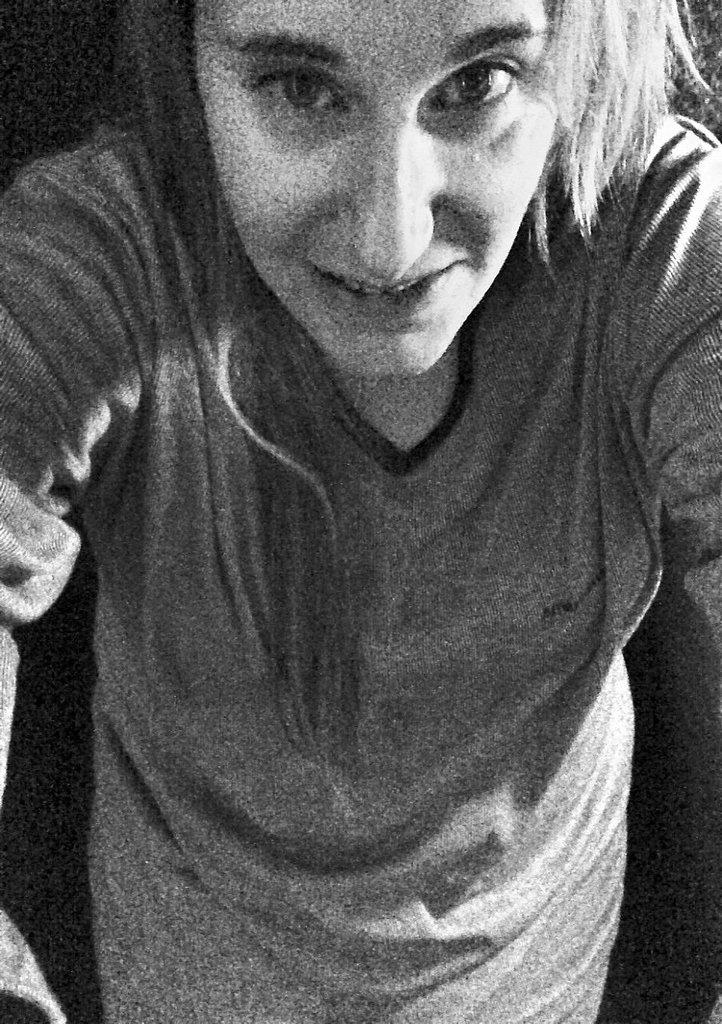What is the main subject of the image? There is a person in the image. What is the person doing in the image? The person is standing. What is the person's facial expression in the image? The person is smiling. What type of business is being conducted in the image? There is no indication of any business being conducted in the image; it simply shows a person standing and smiling. Can you see any hammers in the image? No, there are no hammers visible in the image. 